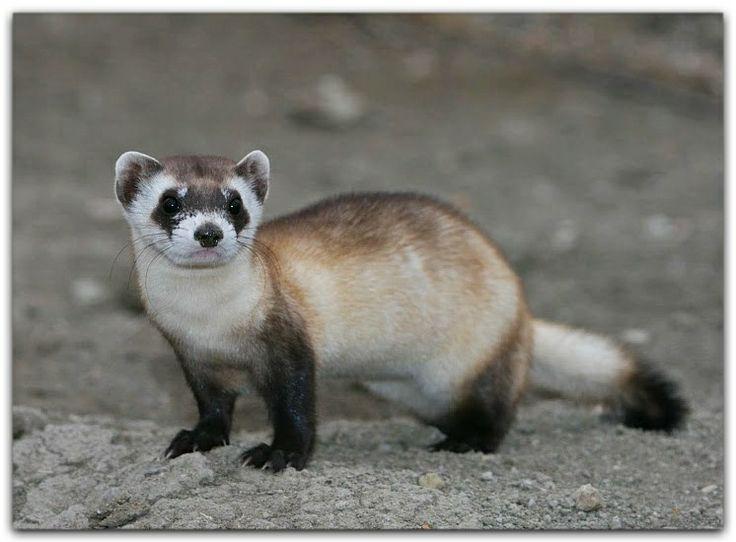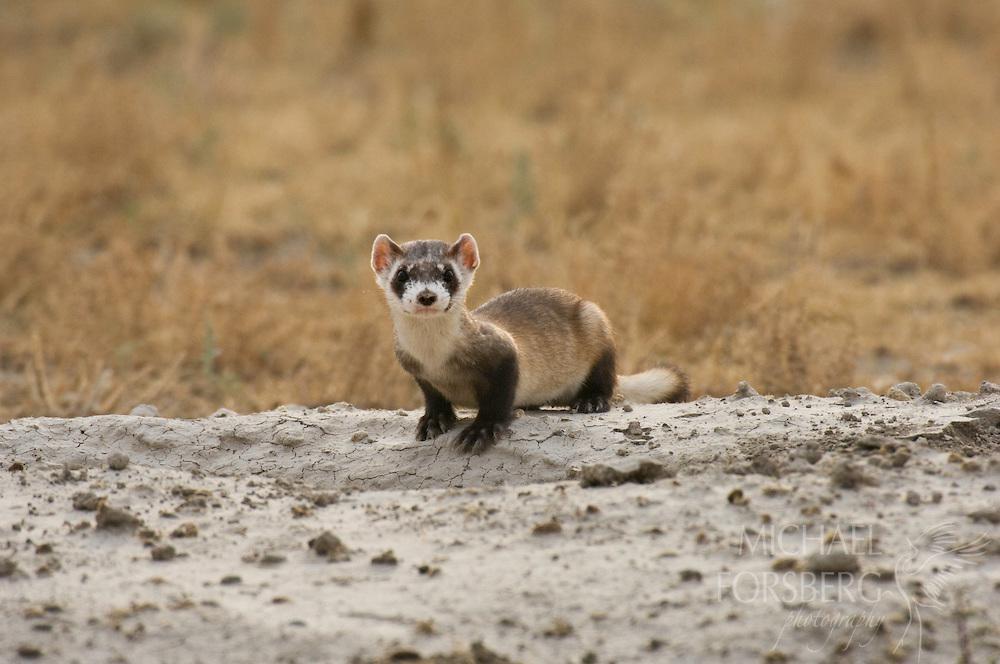The first image is the image on the left, the second image is the image on the right. Examine the images to the left and right. Is the description "There is a pair of ferrets in one image." accurate? Answer yes or no. No. 